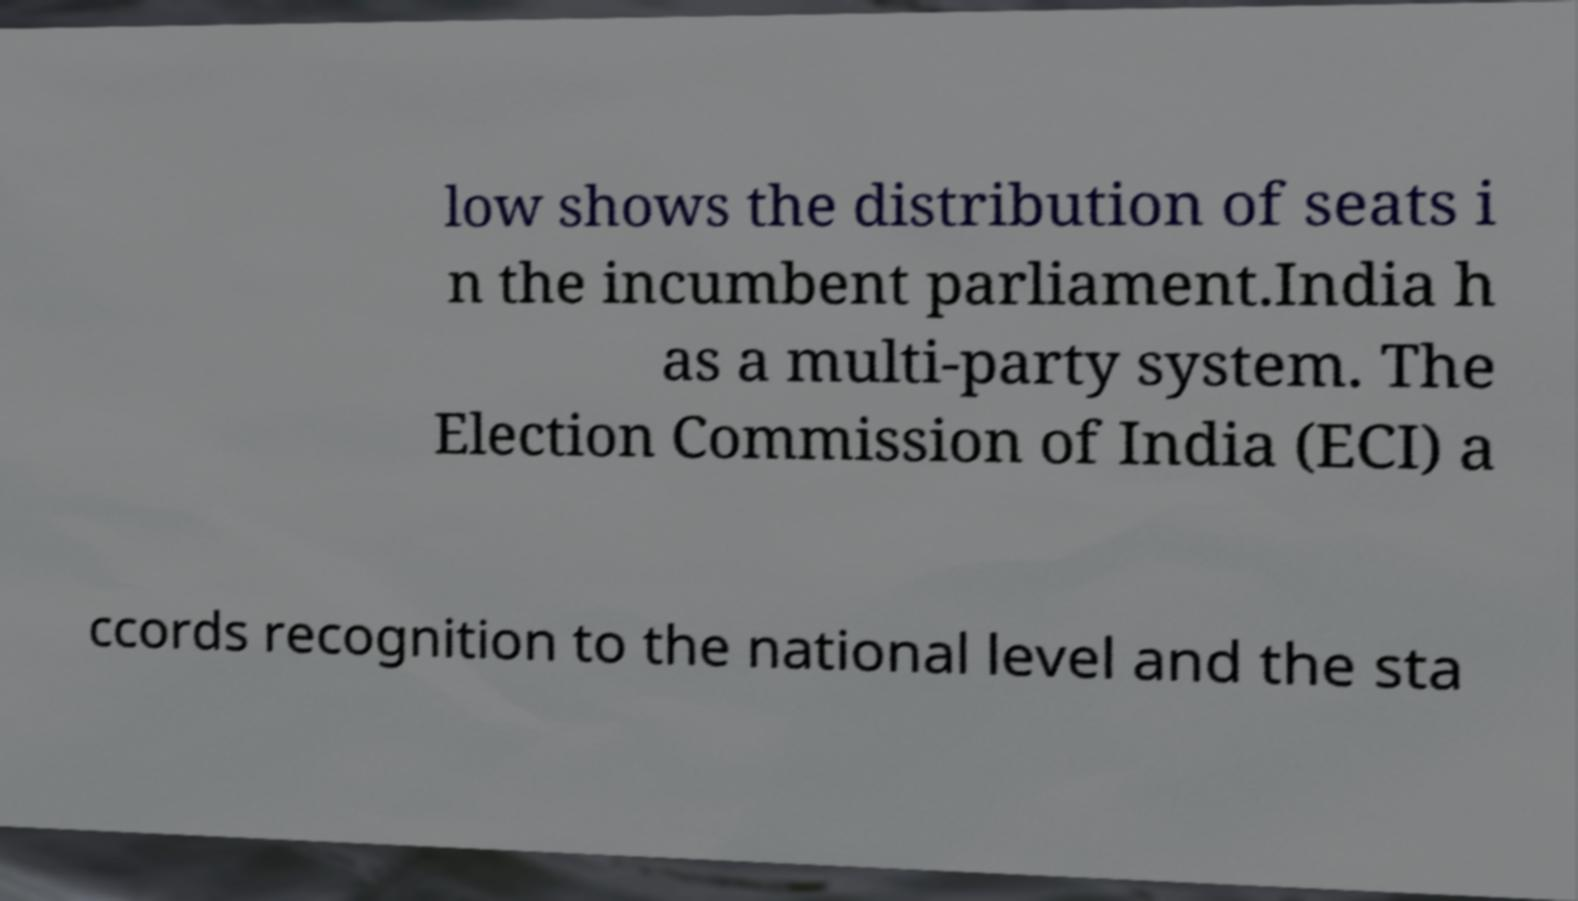Can you accurately transcribe the text from the provided image for me? low shows the distribution of seats i n the incumbent parliament.India h as a multi-party system. The Election Commission of India (ECI) a ccords recognition to the national level and the sta 